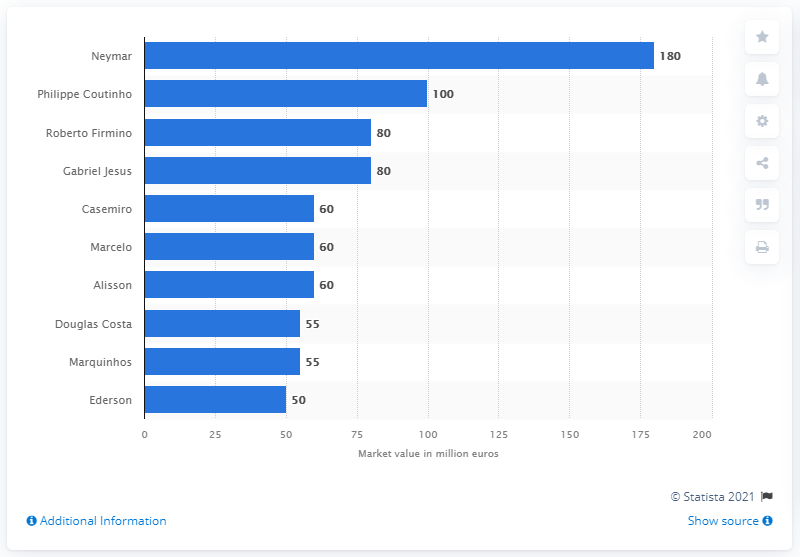Indicate a few pertinent items in this graphic. As of June 2018, Neymar was considered the most valuable Brazilian soccer player. Philippe Coutinho's market value was estimated to be 100.. 